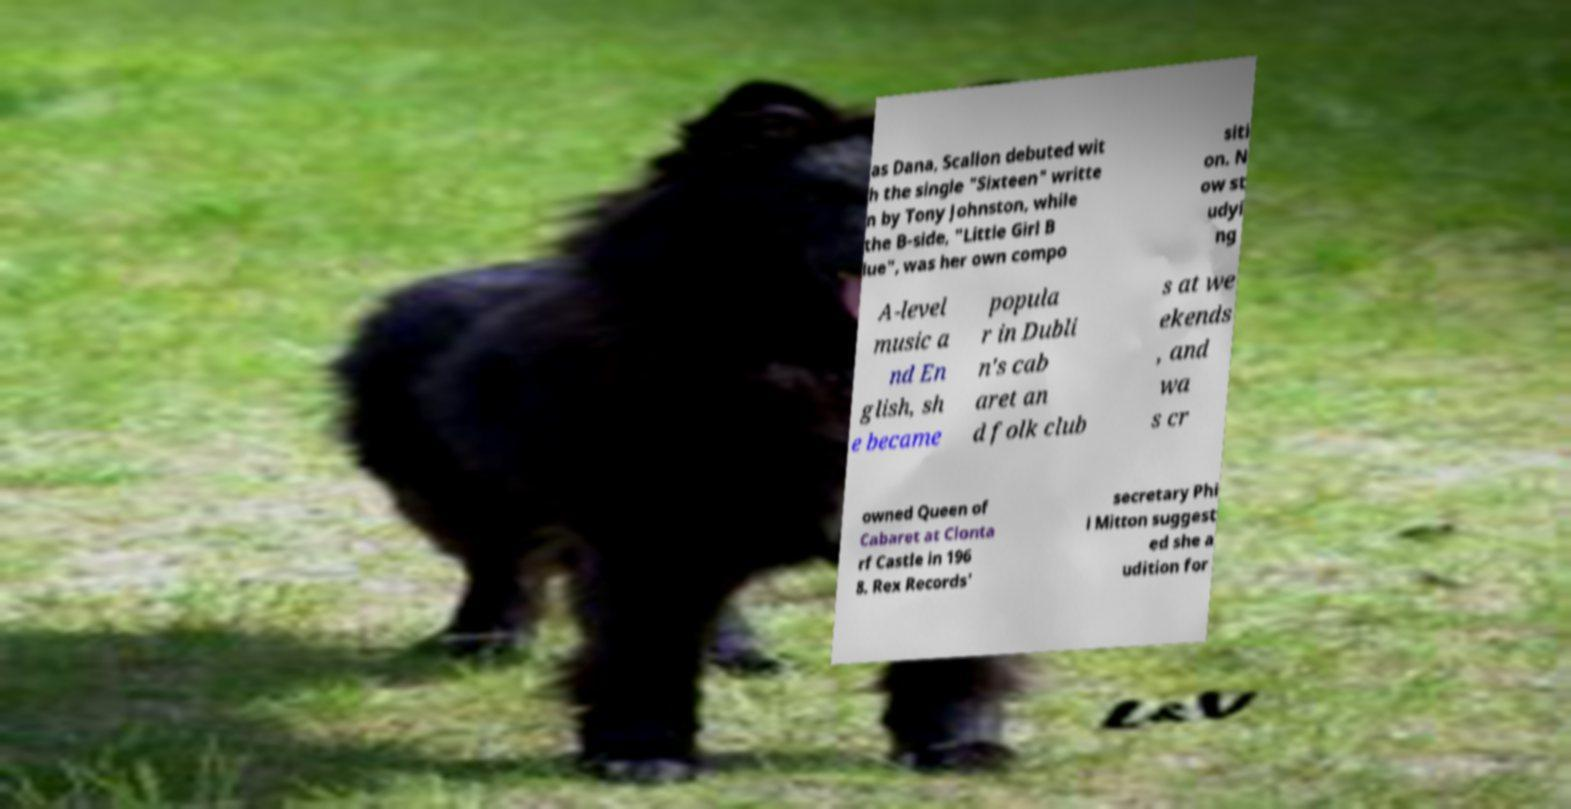There's text embedded in this image that I need extracted. Can you transcribe it verbatim? as Dana, Scallon debuted wit h the single "Sixteen" writte n by Tony Johnston, while the B-side, "Little Girl B lue", was her own compo siti on. N ow st udyi ng A-level music a nd En glish, sh e became popula r in Dubli n's cab aret an d folk club s at we ekends , and wa s cr owned Queen of Cabaret at Clonta rf Castle in 196 8. Rex Records' secretary Phi l Mitton suggest ed she a udition for 